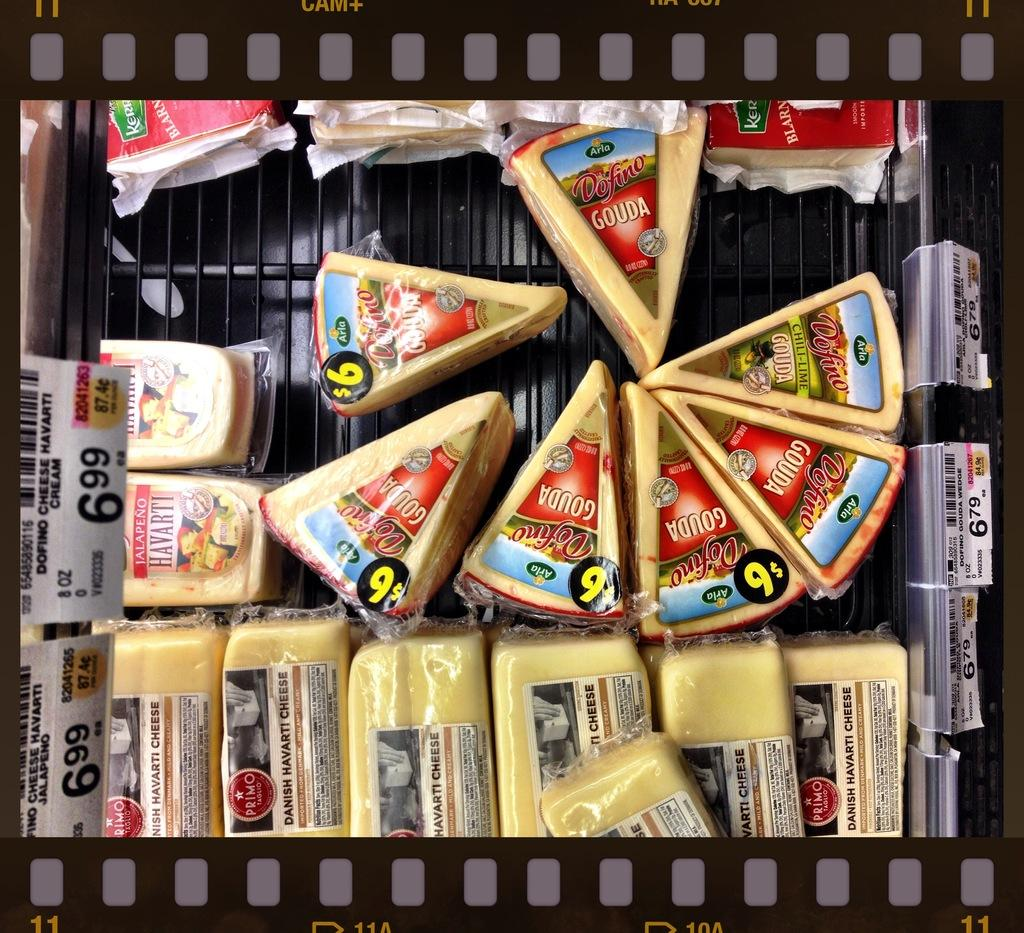<image>
Create a compact narrative representing the image presented. A bin full of variety of cheeses including Gouda different shapes and sizes with a price tag above for $6.99. 